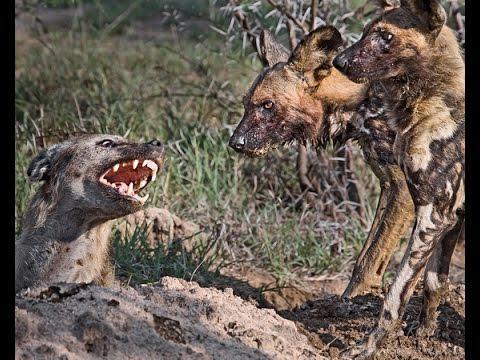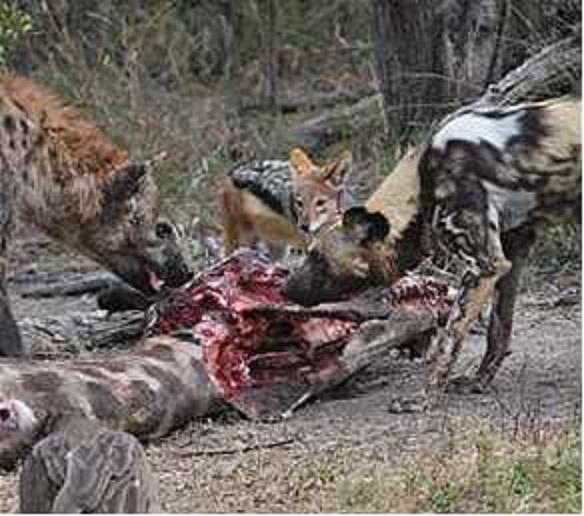The first image is the image on the left, the second image is the image on the right. Assess this claim about the two images: "An image shows different scavenger animals, including hyena, around a carcass.". Correct or not? Answer yes or no. Yes. The first image is the image on the left, the second image is the image on the right. Analyze the images presented: Is the assertion "Hyenas are by a body of water." valid? Answer yes or no. No. 